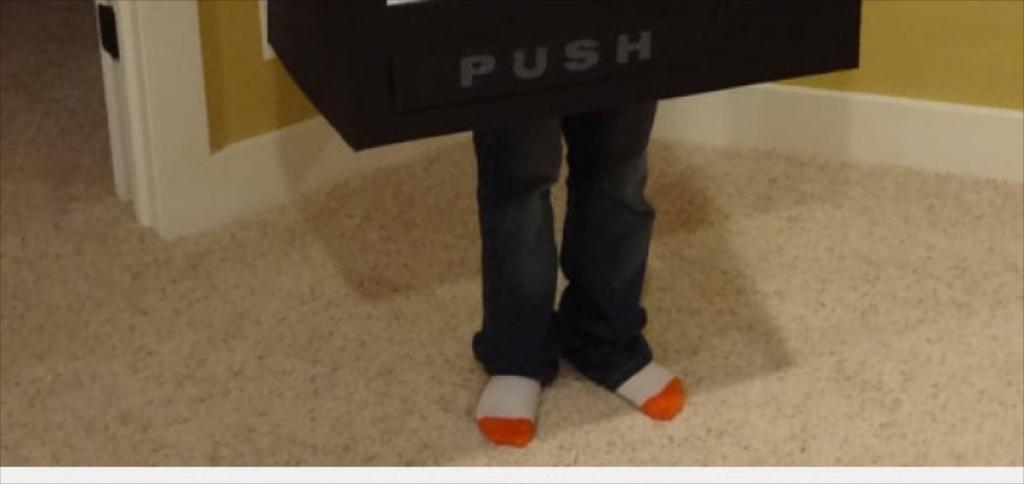Please provide a concise description of this image. In this picture there are two legs in the center of the image and there is a push board at the top side of the image and there is a door in the top left side of the image. 